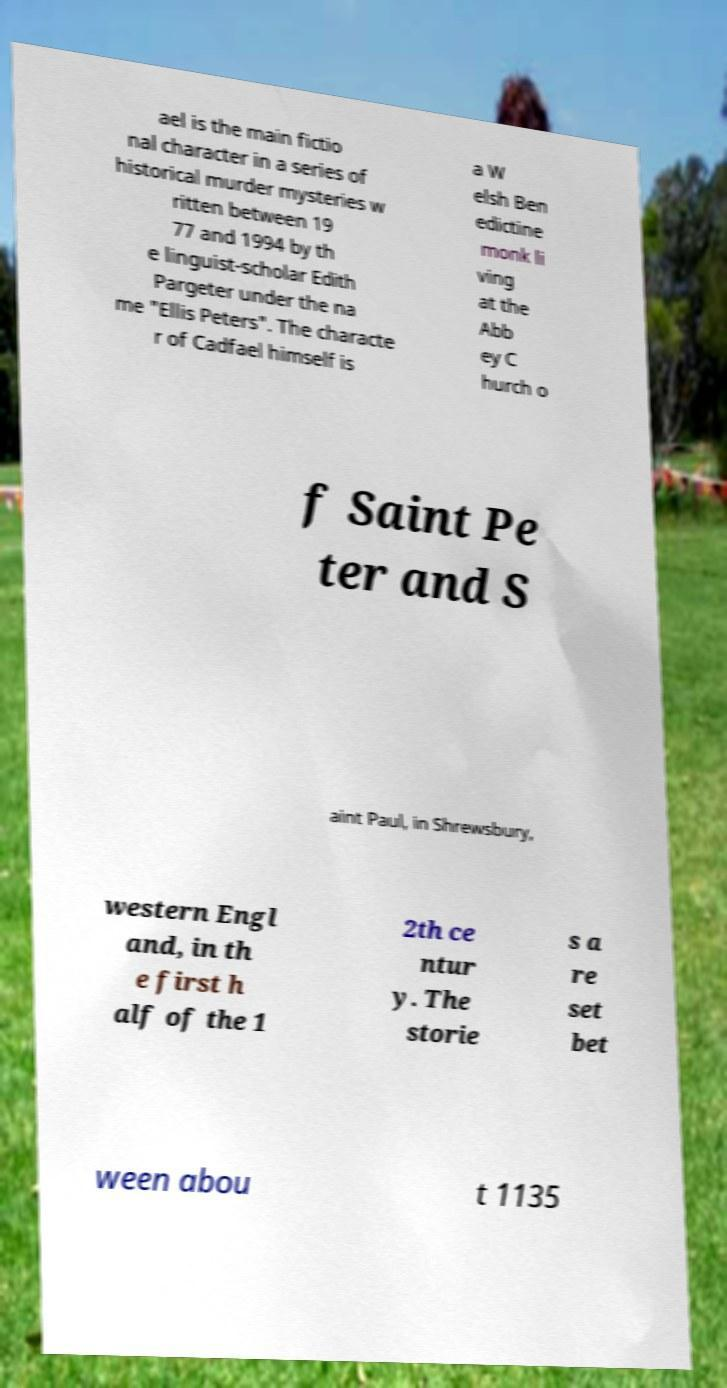I need the written content from this picture converted into text. Can you do that? ael is the main fictio nal character in a series of historical murder mysteries w ritten between 19 77 and 1994 by th e linguist-scholar Edith Pargeter under the na me "Ellis Peters". The characte r of Cadfael himself is a W elsh Ben edictine monk li ving at the Abb ey C hurch o f Saint Pe ter and S aint Paul, in Shrewsbury, western Engl and, in th e first h alf of the 1 2th ce ntur y. The storie s a re set bet ween abou t 1135 